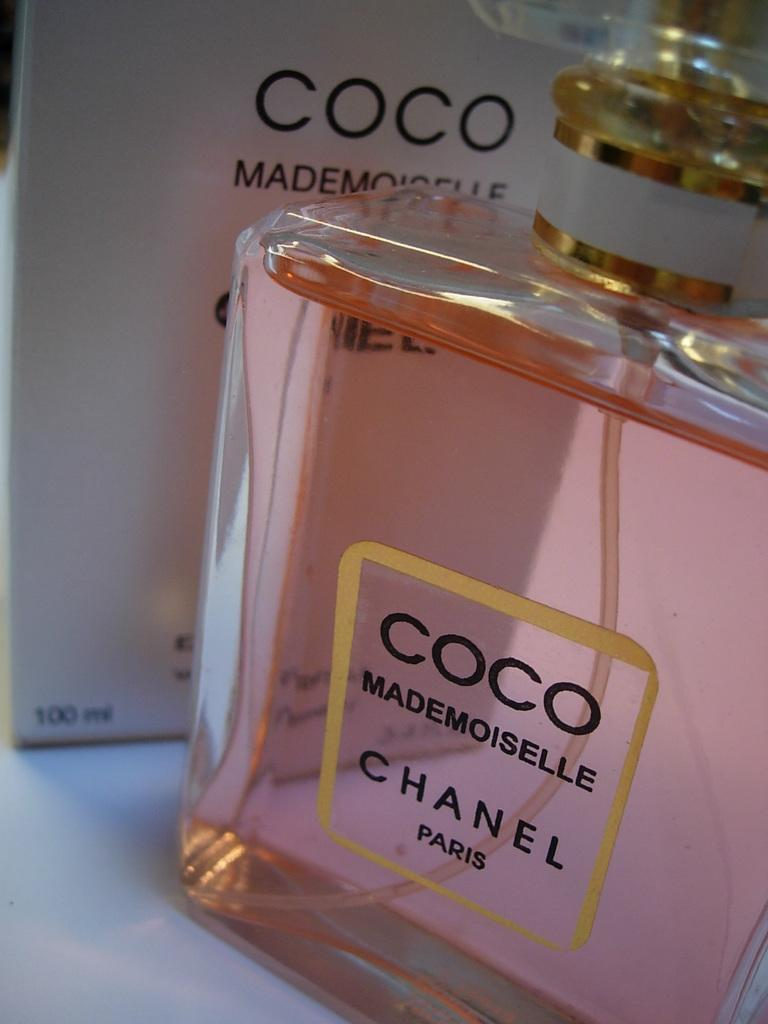<image>
Write a terse but informative summary of the picture. A perfume bottle that is pink with the words Coco Mademoiselle Chanel Paris. 